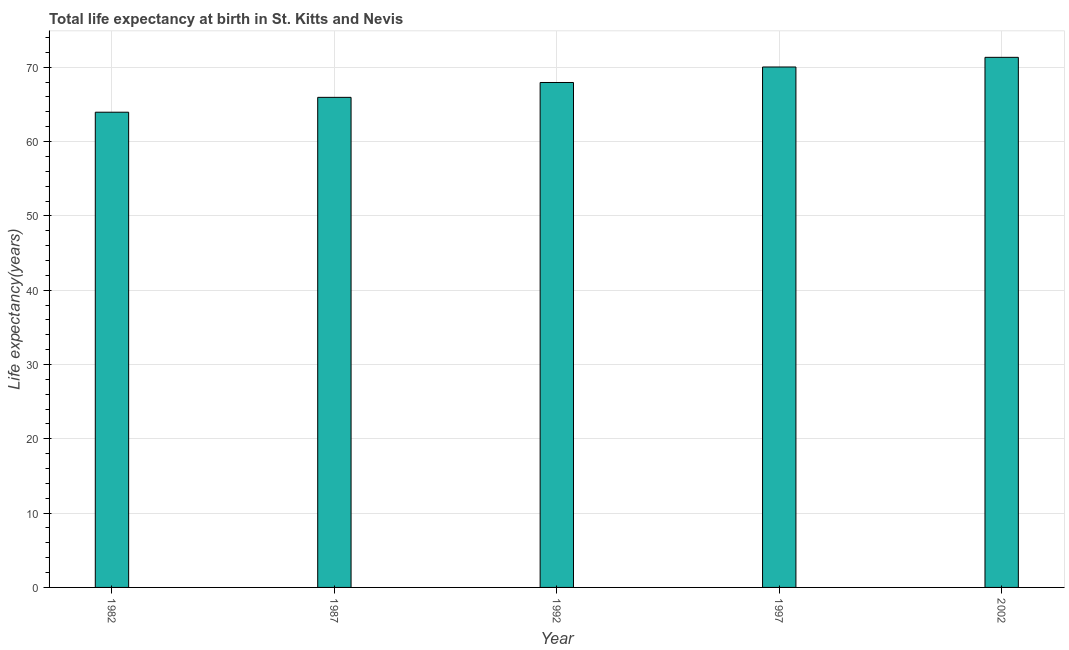Does the graph contain any zero values?
Give a very brief answer. No. Does the graph contain grids?
Your answer should be compact. Yes. What is the title of the graph?
Provide a short and direct response. Total life expectancy at birth in St. Kitts and Nevis. What is the label or title of the X-axis?
Your answer should be very brief. Year. What is the label or title of the Y-axis?
Your response must be concise. Life expectancy(years). What is the life expectancy at birth in 1982?
Your answer should be very brief. 63.95. Across all years, what is the maximum life expectancy at birth?
Your answer should be compact. 71.34. Across all years, what is the minimum life expectancy at birth?
Your response must be concise. 63.95. In which year was the life expectancy at birth maximum?
Keep it short and to the point. 2002. What is the sum of the life expectancy at birth?
Ensure brevity in your answer.  339.23. What is the difference between the life expectancy at birth in 1982 and 1992?
Your response must be concise. -4. What is the average life expectancy at birth per year?
Offer a terse response. 67.84. What is the median life expectancy at birth?
Give a very brief answer. 67.95. What is the ratio of the life expectancy at birth in 1982 to that in 1992?
Provide a succinct answer. 0.94. Is the life expectancy at birth in 1982 less than that in 2002?
Provide a succinct answer. Yes. Is the difference between the life expectancy at birth in 1997 and 2002 greater than the difference between any two years?
Offer a terse response. No. What is the difference between the highest and the second highest life expectancy at birth?
Make the answer very short. 1.3. What is the difference between the highest and the lowest life expectancy at birth?
Make the answer very short. 7.39. What is the difference between two consecutive major ticks on the Y-axis?
Give a very brief answer. 10. What is the Life expectancy(years) of 1982?
Make the answer very short. 63.95. What is the Life expectancy(years) in 1987?
Your response must be concise. 65.95. What is the Life expectancy(years) of 1992?
Give a very brief answer. 67.95. What is the Life expectancy(years) in 1997?
Give a very brief answer. 70.04. What is the Life expectancy(years) in 2002?
Provide a succinct answer. 71.34. What is the difference between the Life expectancy(years) in 1982 and 1992?
Your answer should be very brief. -4. What is the difference between the Life expectancy(years) in 1982 and 1997?
Your answer should be compact. -6.09. What is the difference between the Life expectancy(years) in 1982 and 2002?
Your answer should be very brief. -7.39. What is the difference between the Life expectancy(years) in 1987 and 1997?
Offer a terse response. -4.09. What is the difference between the Life expectancy(years) in 1987 and 2002?
Offer a terse response. -5.39. What is the difference between the Life expectancy(years) in 1992 and 1997?
Your response must be concise. -2.09. What is the difference between the Life expectancy(years) in 1992 and 2002?
Make the answer very short. -3.39. What is the difference between the Life expectancy(years) in 1997 and 2002?
Keep it short and to the point. -1.3. What is the ratio of the Life expectancy(years) in 1982 to that in 1987?
Your answer should be compact. 0.97. What is the ratio of the Life expectancy(years) in 1982 to that in 1992?
Ensure brevity in your answer.  0.94. What is the ratio of the Life expectancy(years) in 1982 to that in 2002?
Your response must be concise. 0.9. What is the ratio of the Life expectancy(years) in 1987 to that in 1997?
Your answer should be compact. 0.94. What is the ratio of the Life expectancy(years) in 1987 to that in 2002?
Make the answer very short. 0.93. What is the ratio of the Life expectancy(years) in 1992 to that in 1997?
Make the answer very short. 0.97. What is the ratio of the Life expectancy(years) in 1992 to that in 2002?
Provide a succinct answer. 0.95. What is the ratio of the Life expectancy(years) in 1997 to that in 2002?
Your answer should be compact. 0.98. 